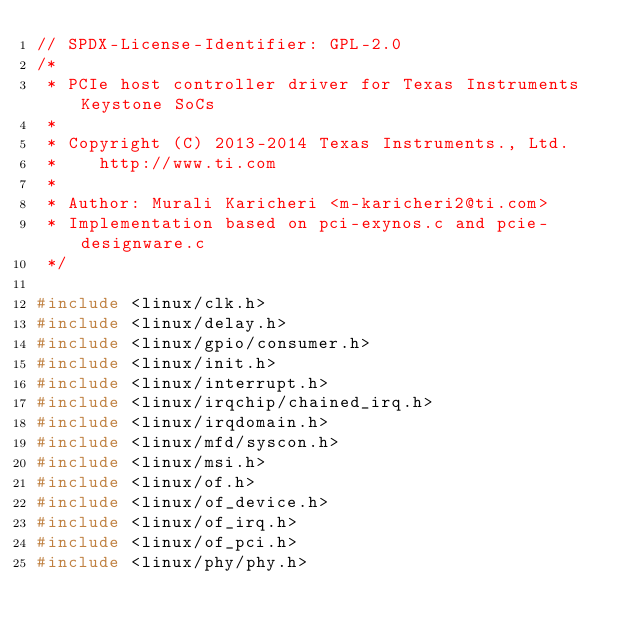Convert code to text. <code><loc_0><loc_0><loc_500><loc_500><_C_>// SPDX-License-Identifier: GPL-2.0
/*
 * PCIe host controller driver for Texas Instruments Keystone SoCs
 *
 * Copyright (C) 2013-2014 Texas Instruments., Ltd.
 *		http://www.ti.com
 *
 * Author: Murali Karicheri <m-karicheri2@ti.com>
 * Implementation based on pci-exynos.c and pcie-designware.c
 */

#include <linux/clk.h>
#include <linux/delay.h>
#include <linux/gpio/consumer.h>
#include <linux/init.h>
#include <linux/interrupt.h>
#include <linux/irqchip/chained_irq.h>
#include <linux/irqdomain.h>
#include <linux/mfd/syscon.h>
#include <linux/msi.h>
#include <linux/of.h>
#include <linux/of_device.h>
#include <linux/of_irq.h>
#include <linux/of_pci.h>
#include <linux/phy/phy.h></code> 